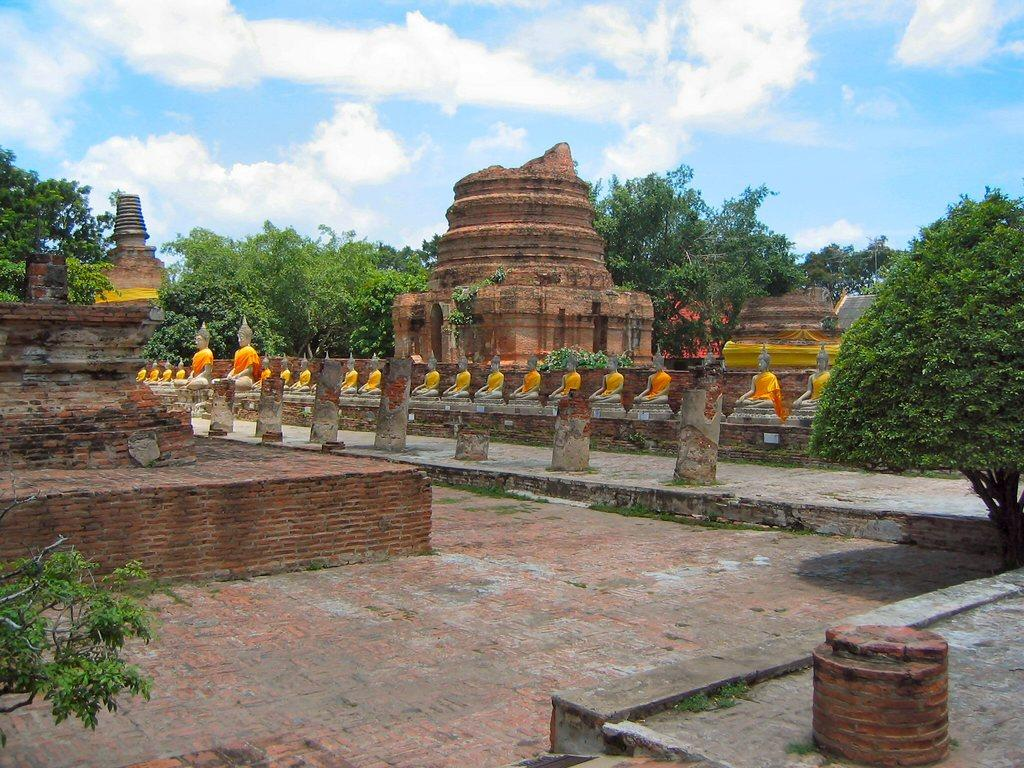What is located in the middle of the image? There are trees, a fort, a wall, statues, stones, and a floor in the middle of the image. Can you describe the fort in the image? The fort is located in the middle of the image. What is the condition of the sky in the image? The sky is visible at the top of the image, and clouds are present in the sky. What decision was made by the wilderness in the image? There is no wilderness present in the image, and therefore no decision can be attributed to it. What part of the fort is made of a different material than the rest? The image does not provide information about the materials used in the construction of the fort, so it is not possible to answer this question. 